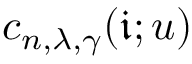Convert formula to latex. <formula><loc_0><loc_0><loc_500><loc_500>c _ { n , \lambda , \gamma } ( \mathfrak { i } ; u )</formula> 